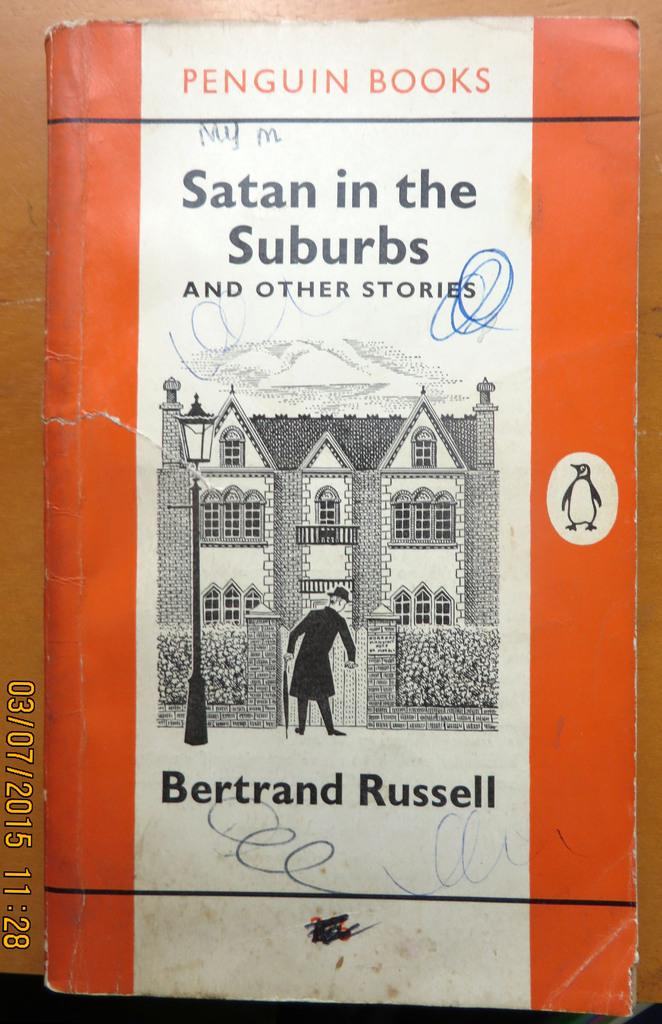<image>
Write a terse but informative summary of the picture. a book that was written by Bertrand Russell 